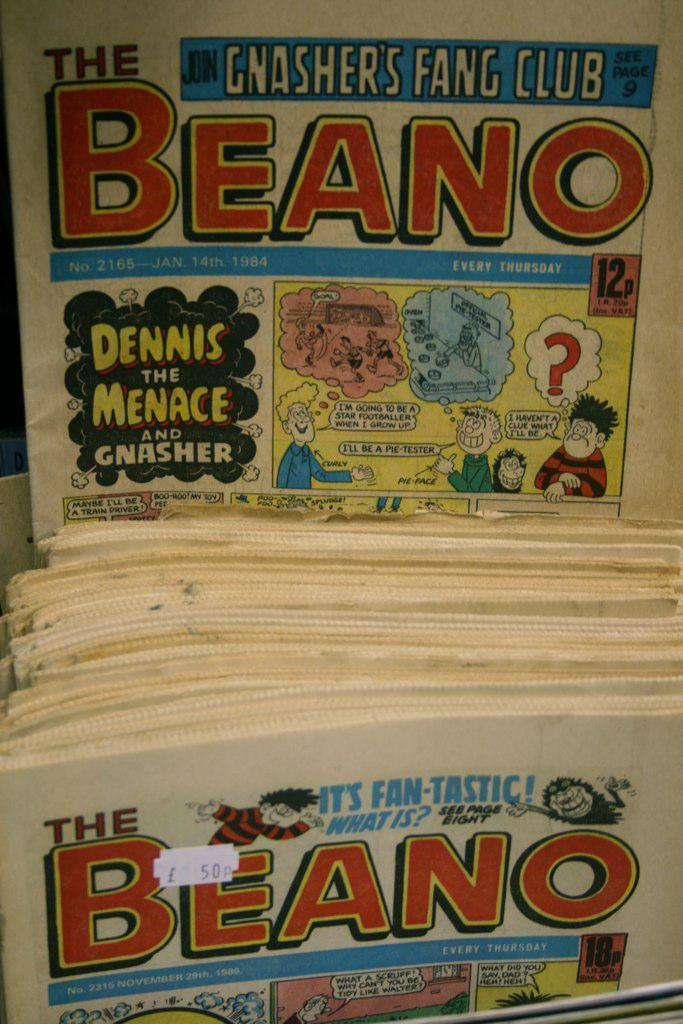<image>
Give a short and clear explanation of the subsequent image. Vintage magazine comic of The Beano from the Gnasher's Fang Club. 